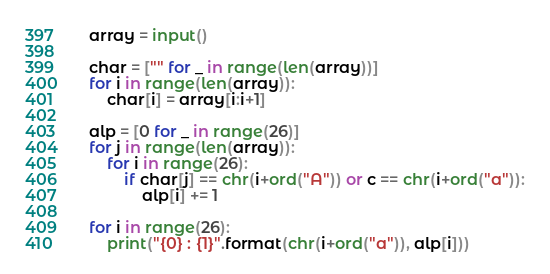Convert code to text. <code><loc_0><loc_0><loc_500><loc_500><_Python_>array = input()

char = ["" for _ in range(len(array))]
for i in range(len(array)):
    char[i] = array[i:i+1]

alp = [0 for _ in range(26)]
for j in range(len(array)):
    for i in range(26):
        if char[j] == chr(i+ord("A")) or c == chr(i+ord("a")):
            alp[i] += 1

for i in range(26):
    print("{0} : {1}".format(chr(i+ord("a")), alp[i]))</code> 